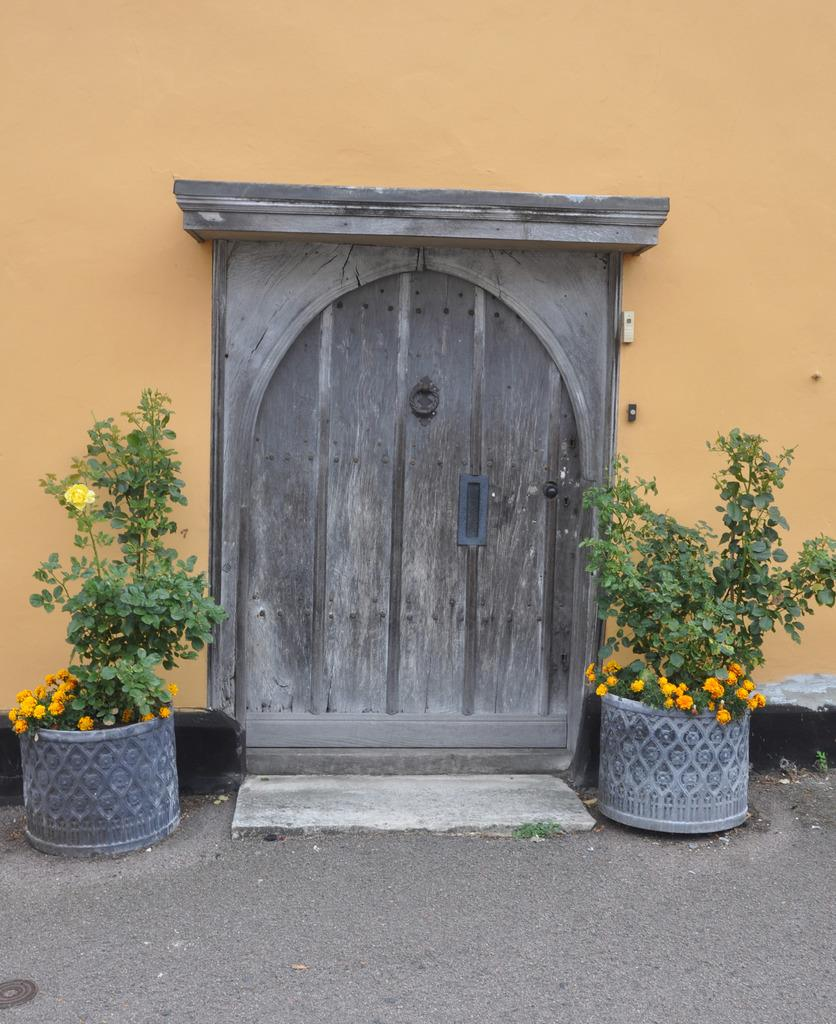What type of plants can be seen in the image? There are house plants with flowers in the image. Where are the house plants located? The house plants are on the ground. What architectural feature is visible in the image? There is a door visible in the image. What is the background of the image made of? There is a wall in the image. Can you describe any objects present in the image? There are objects present in the image, but their specific nature is not mentioned in the provided facts. What is the committee's decision regarding the pocket size in the image? There is no committee, pocket, or decision present in the image; it features house plants with flowers on the ground, a door, and a wall. 